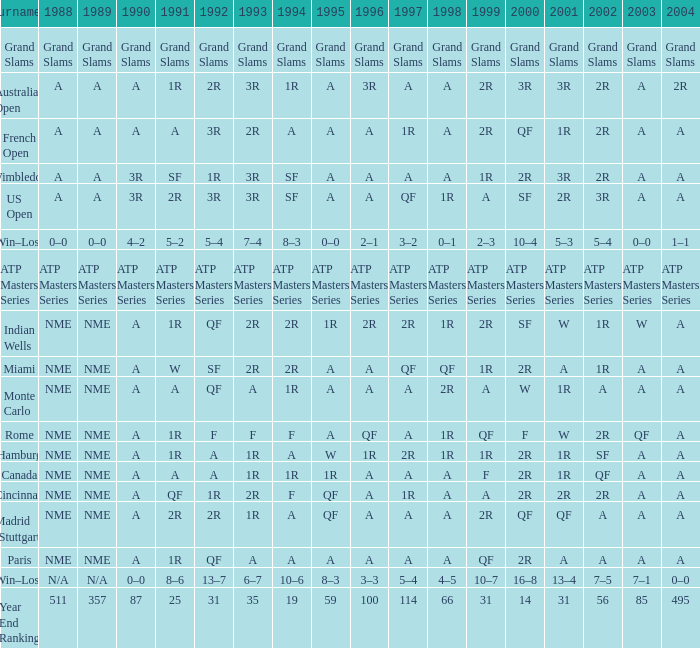What demonstrates for 2002 when the 1991 is w? 1R. 